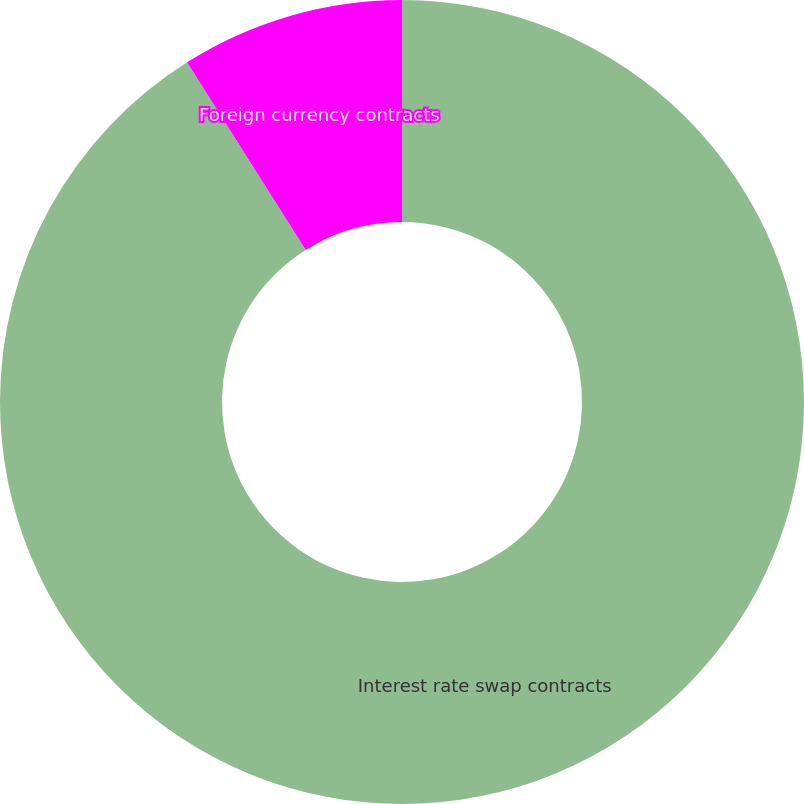<chart> <loc_0><loc_0><loc_500><loc_500><pie_chart><fcel>Interest rate swap contracts<fcel>Foreign currency contracts<nl><fcel>91.02%<fcel>8.98%<nl></chart> 